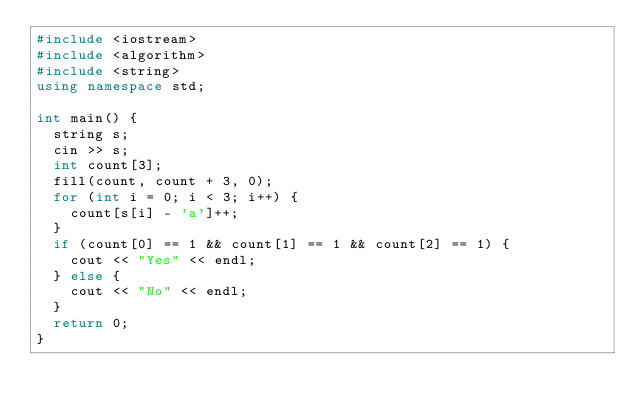Convert code to text. <code><loc_0><loc_0><loc_500><loc_500><_C++_>#include <iostream>
#include <algorithm>
#include <string>
using namespace std;

int main() {
  string s;
  cin >> s;
  int count[3];
  fill(count, count + 3, 0);
  for (int i = 0; i < 3; i++) {
    count[s[i] - 'a']++;
  }
  if (count[0] == 1 && count[1] == 1 && count[2] == 1) {
    cout << "Yes" << endl;
  } else {
    cout << "No" << endl;
  }
  return 0;
}
</code> 